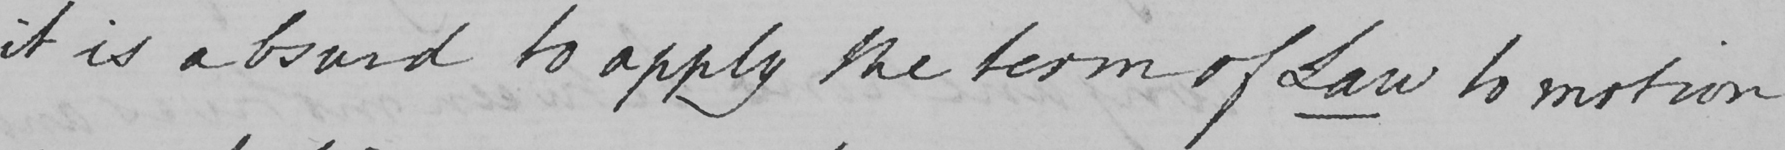What does this handwritten line say? it is absurd to apply the term of Law to motion 